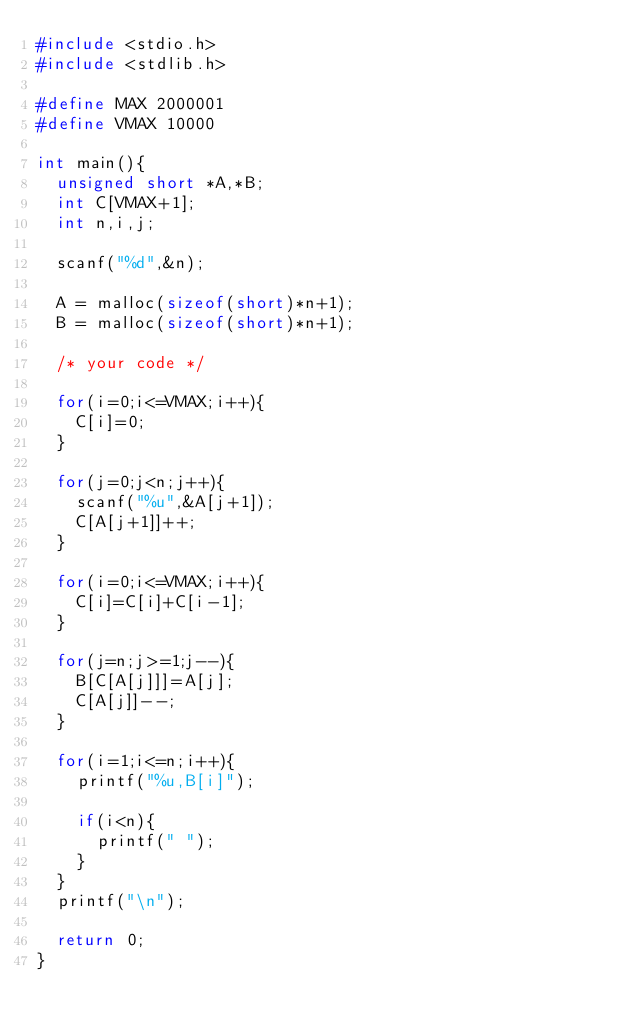Convert code to text. <code><loc_0><loc_0><loc_500><loc_500><_C_>#include <stdio.h>
#include <stdlib.h>

#define MAX 2000001
#define VMAX 10000

int main(){
  unsigned short *A,*B;
  int C[VMAX+1];
  int n,i,j;

  scanf("%d",&n);

  A = malloc(sizeof(short)*n+1);
  B = malloc(sizeof(short)*n+1);

  /* your code */

  for(i=0;i<=VMAX;i++){
    C[i]=0;
  }

  for(j=0;j<n;j++){
    scanf("%u",&A[j+1]);
    C[A[j+1]]++;
  }

  for(i=0;i<=VMAX;i++){
    C[i]=C[i]+C[i-1];
  }

  for(j=n;j>=1;j--){
    B[C[A[j]]]=A[j];
    C[A[j]]--;
  }

  for(i=1;i<=n;i++){
    printf("%u,B[i]");

    if(i<n){
      printf(" ");
    }
  }
  printf("\n");

  return 0;
}
</code> 